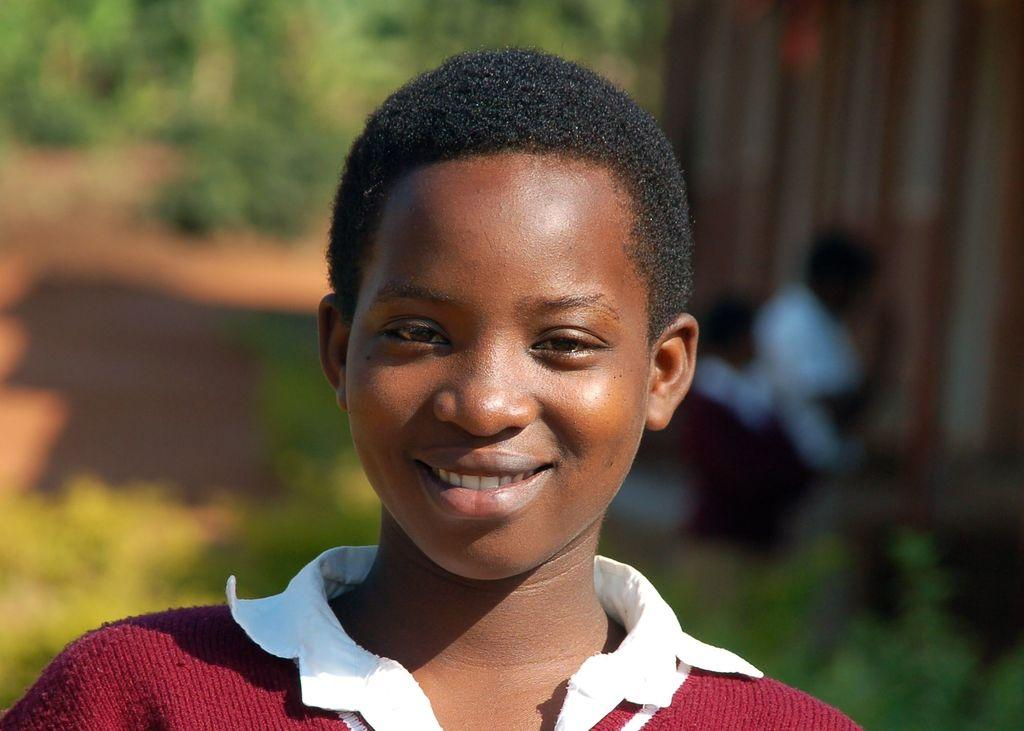Who is the main subject in the image? There is a boy in the image. What is the boy doing in the image? The boy is smiling. What can be seen in the background of the image? There are plants and other people standing on the ground, but they appear blurry. What type of jam is the boy holding in the image? There is no jam present in the image; the boy is simply smiling. How many tomatoes can be seen on the boy's tongue in the image? There are no tomatoes or any food items on the boy's tongue in the image. 